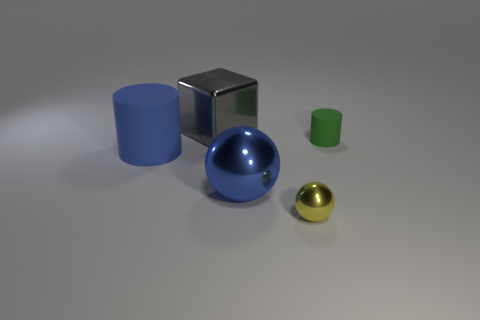Can you describe the relative sizes and colors of the objects in the image? Certainly! From left to right, we have a medium-sized blue cylinder, a large silver cube, a large blue sphere, a small green cylinder, and a tiny golden sphere. These objects are set against a neutral background, which accentuates their colors. 